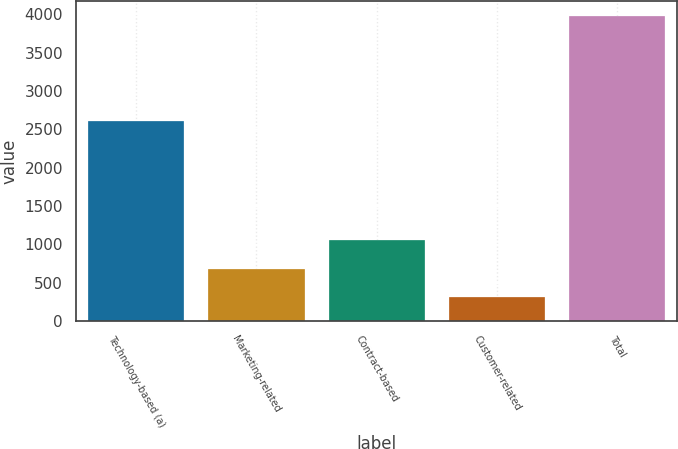<chart> <loc_0><loc_0><loc_500><loc_500><bar_chart><fcel>Technology-based (a)<fcel>Marketing-related<fcel>Contract-based<fcel>Customer-related<fcel>Total<nl><fcel>2615<fcel>685.5<fcel>1051<fcel>320<fcel>3975<nl></chart> 